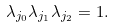<formula> <loc_0><loc_0><loc_500><loc_500>\lambda _ { j _ { 0 } } \lambda _ { j _ { 1 } } \lambda _ { j _ { 2 } } = 1 .</formula> 